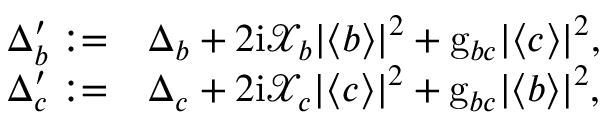Convert formula to latex. <formula><loc_0><loc_0><loc_500><loc_500>\begin{array} { r l } { \Delta _ { b } ^ { \prime } \colon = } & { \Delta _ { b } + 2 i \mathcal { X } _ { b } | \langle b \rangle | ^ { 2 } + g _ { b c } | \langle c \rangle | ^ { 2 } , } \\ { \Delta _ { c } ^ { \prime } \colon = } & { \Delta _ { c } + 2 i \mathcal { X } _ { c } | \langle c \rangle | ^ { 2 } + g _ { b c } | \langle b \rangle | ^ { 2 } , } \end{array}</formula> 